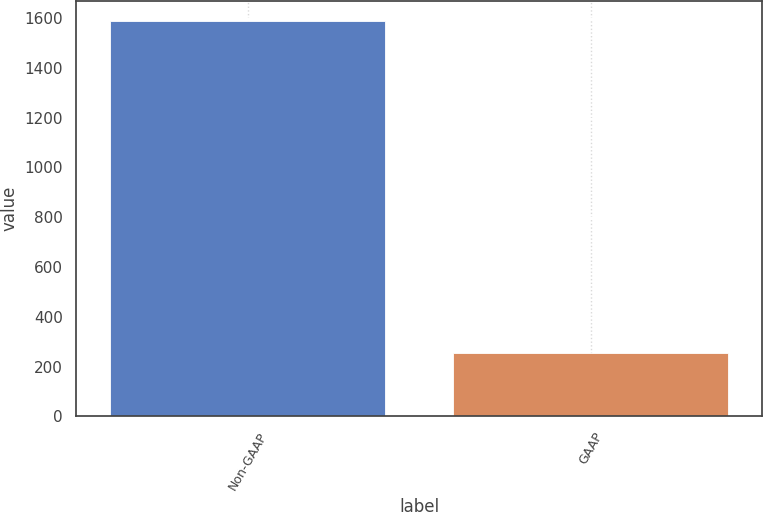Convert chart. <chart><loc_0><loc_0><loc_500><loc_500><bar_chart><fcel>Non-GAAP<fcel>GAAP<nl><fcel>1589<fcel>256<nl></chart> 